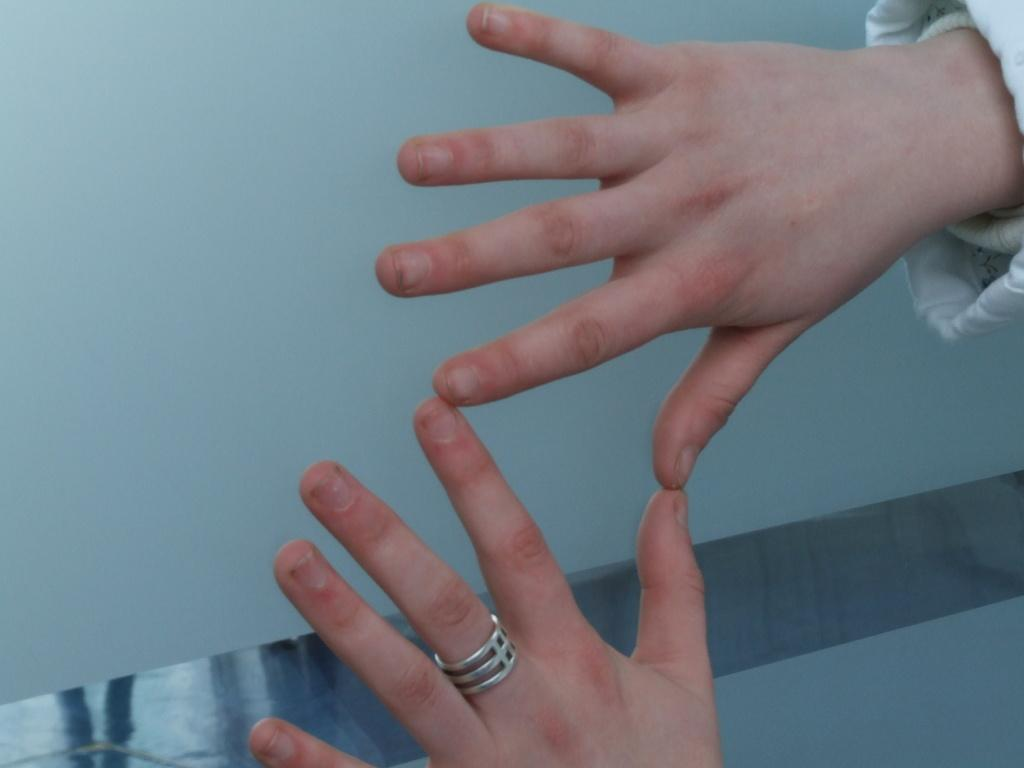What can be seen in the image? There is a person in the image. What is the person wearing? The person is wearing a white dress. What part of the person's body is visible in the image? The person's hands are visible in the image. Can you describe any accessories the person is wearing? The person is wearing a silver-colored ring on their finger. What is visible in the background of the image? There is a wall in the background of the image. What type of bubble can be seen floating near the person in the image? There is no bubble present in the image. How many jellyfish are visible in the image? There are no jellyfish present in the image. 